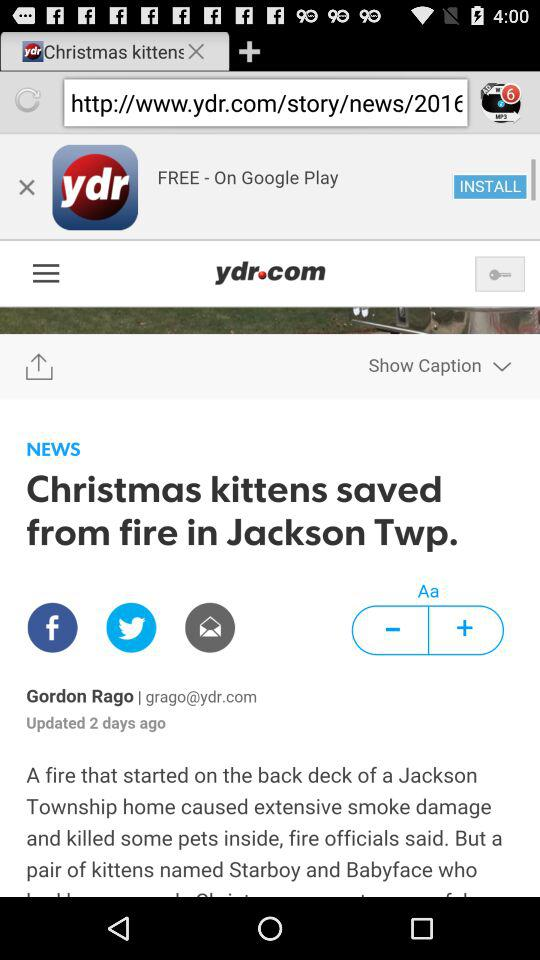When was the news updated? The news was updated 2 days ago. 